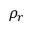Convert formula to latex. <formula><loc_0><loc_0><loc_500><loc_500>\rho _ { r }</formula> 